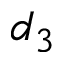<formula> <loc_0><loc_0><loc_500><loc_500>d _ { 3 }</formula> 